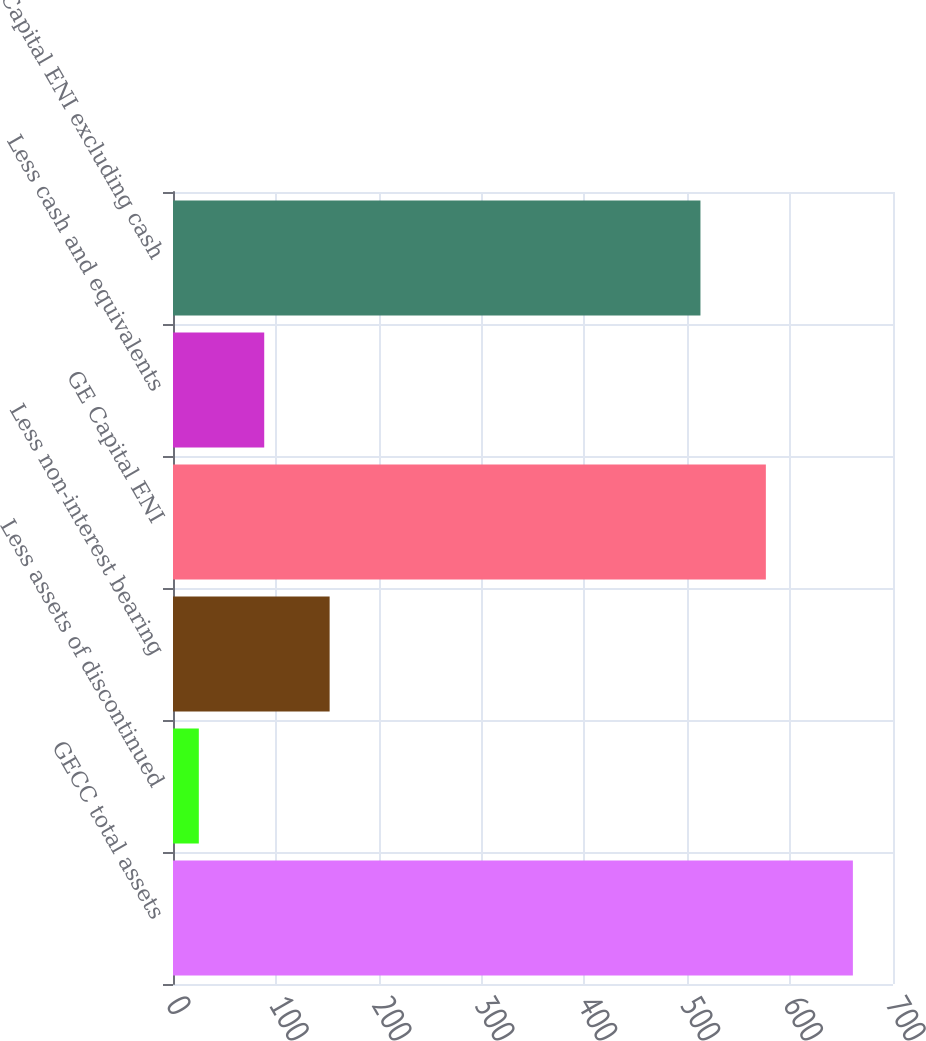Convert chart. <chart><loc_0><loc_0><loc_500><loc_500><bar_chart><fcel>GECC total assets<fcel>Less assets of discontinued<fcel>Less non-interest bearing<fcel>GE Capital ENI<fcel>Less cash and equivalents<fcel>GE Capital ENI excluding cash<nl><fcel>661<fcel>25.1<fcel>152.28<fcel>576.39<fcel>88.69<fcel>512.8<nl></chart> 